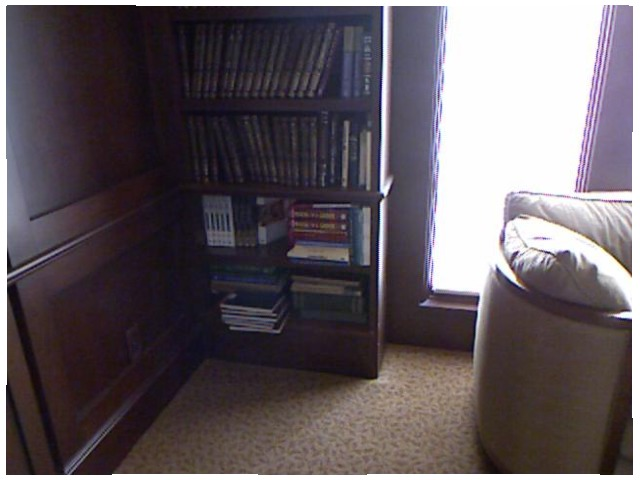<image>
Can you confirm if the book is on the shelf? Yes. Looking at the image, I can see the book is positioned on top of the shelf, with the shelf providing support. Where is the wall in relation to the couch? Is it next to the couch? No. The wall is not positioned next to the couch. They are located in different areas of the scene. 